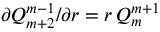Convert formula to latex. <formula><loc_0><loc_0><loc_500><loc_500>\partial Q _ { m + 2 } ^ { m - 1 } / \partial r = r \, Q _ { m } ^ { m + 1 }</formula> 